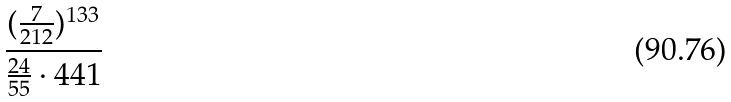<formula> <loc_0><loc_0><loc_500><loc_500>\frac { ( \frac { 7 } { 2 1 2 } ) ^ { 1 3 3 } } { \frac { 2 4 } { 5 5 } \cdot 4 4 1 }</formula> 